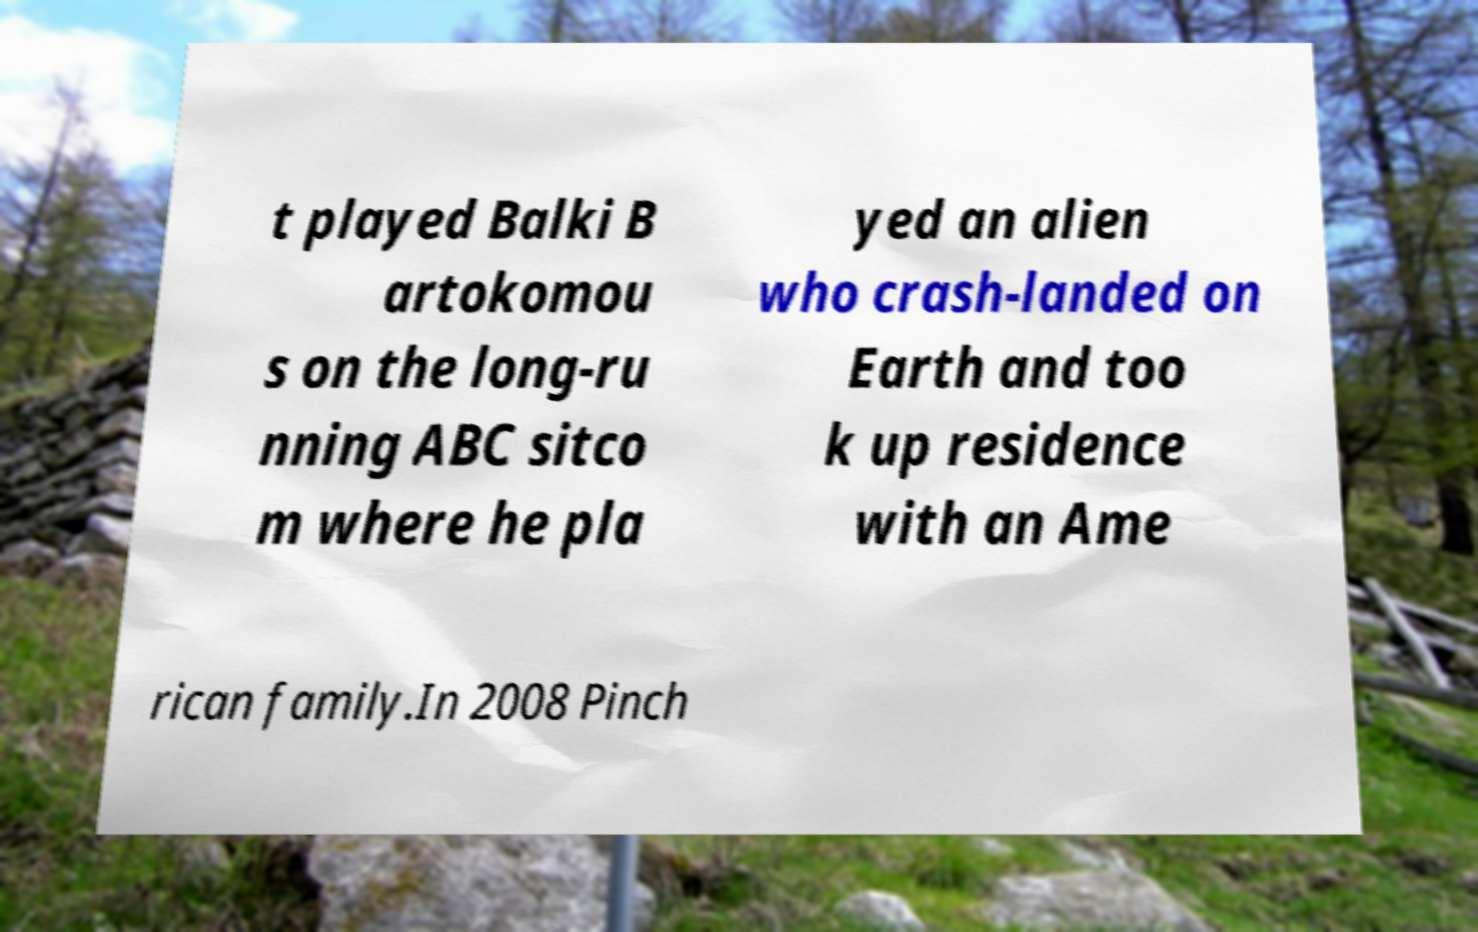Can you read and provide the text displayed in the image?This photo seems to have some interesting text. Can you extract and type it out for me? t played Balki B artokomou s on the long-ru nning ABC sitco m where he pla yed an alien who crash-landed on Earth and too k up residence with an Ame rican family.In 2008 Pinch 